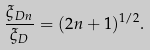<formula> <loc_0><loc_0><loc_500><loc_500>\frac { \xi _ { D n } } { \xi _ { D } } = ( 2 n + 1 ) ^ { 1 / 2 } .</formula> 